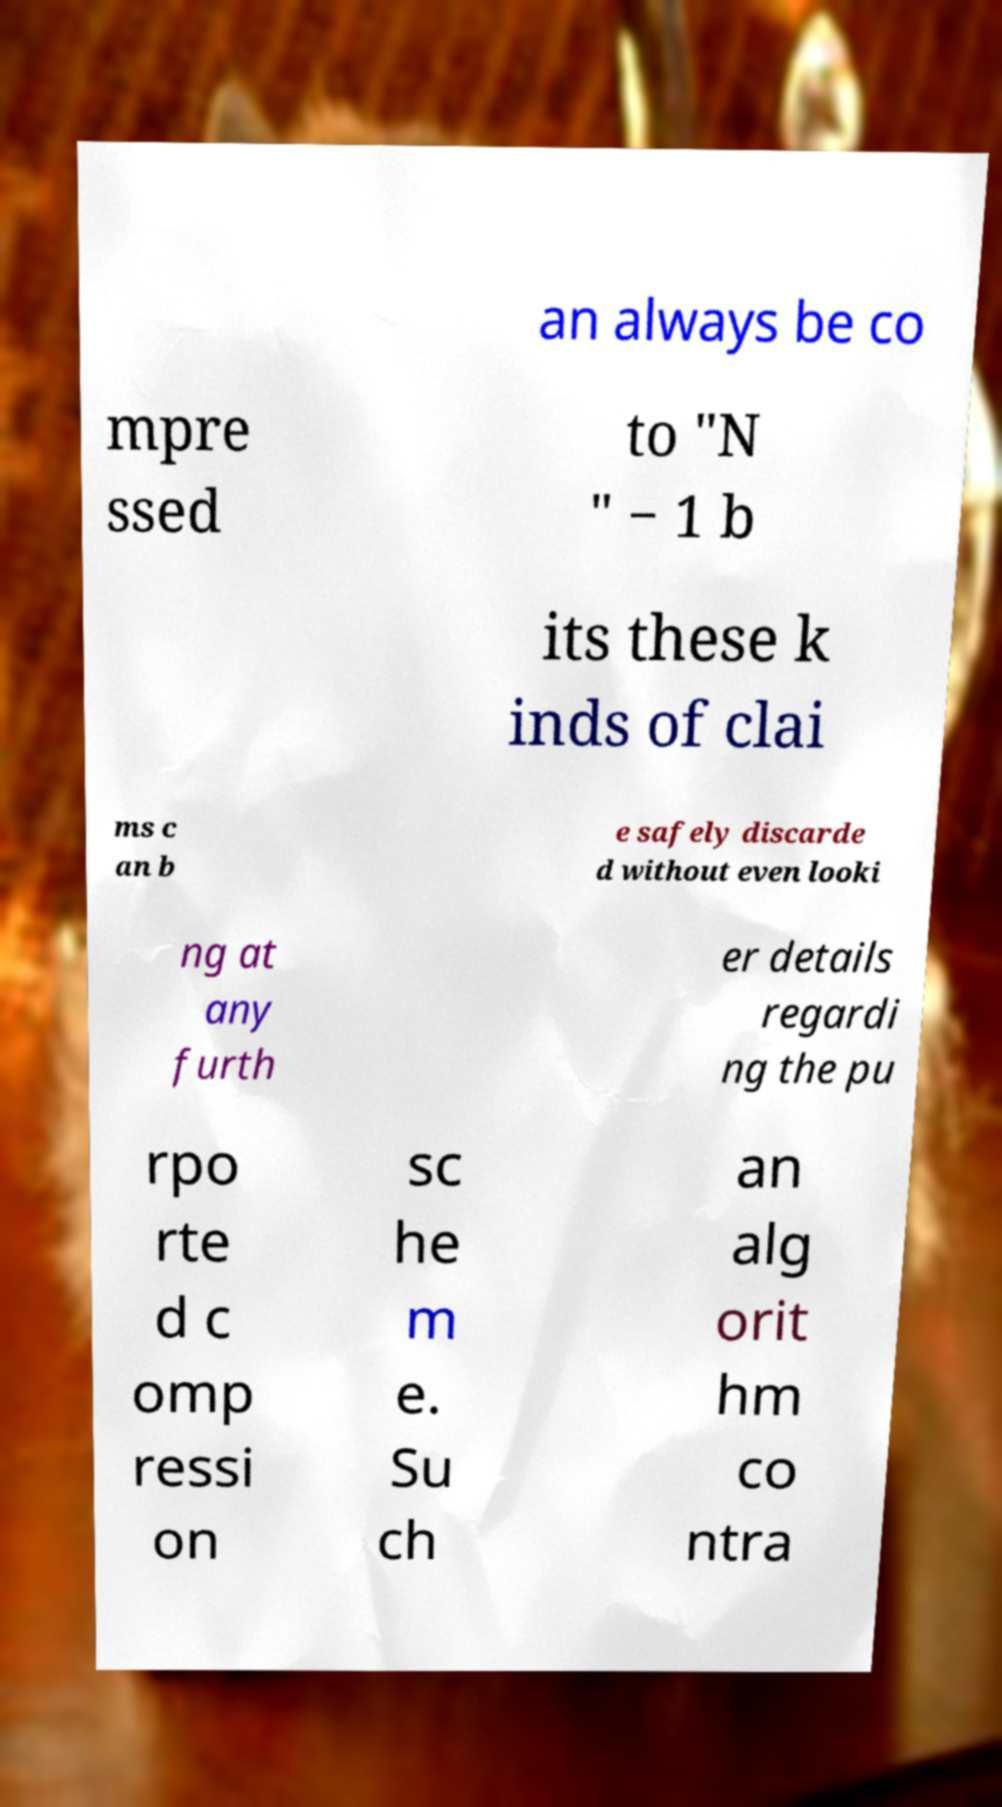Can you accurately transcribe the text from the provided image for me? an always be co mpre ssed to "N " − 1 b its these k inds of clai ms c an b e safely discarde d without even looki ng at any furth er details regardi ng the pu rpo rte d c omp ressi on sc he m e. Su ch an alg orit hm co ntra 